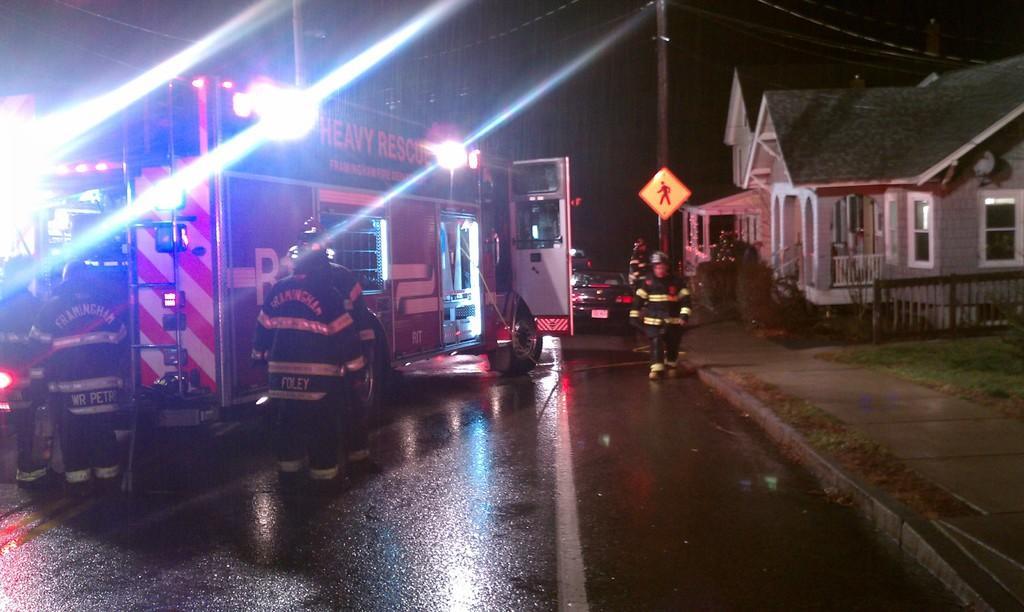In one or two sentences, can you explain what this image depicts? In the image we can see there is a road and there are five people on road. The four people are standing on the road and the other one is walking on the road and there is car and bus on the road and right side there is house with green color rooftop and in front of the house there is a plant. 